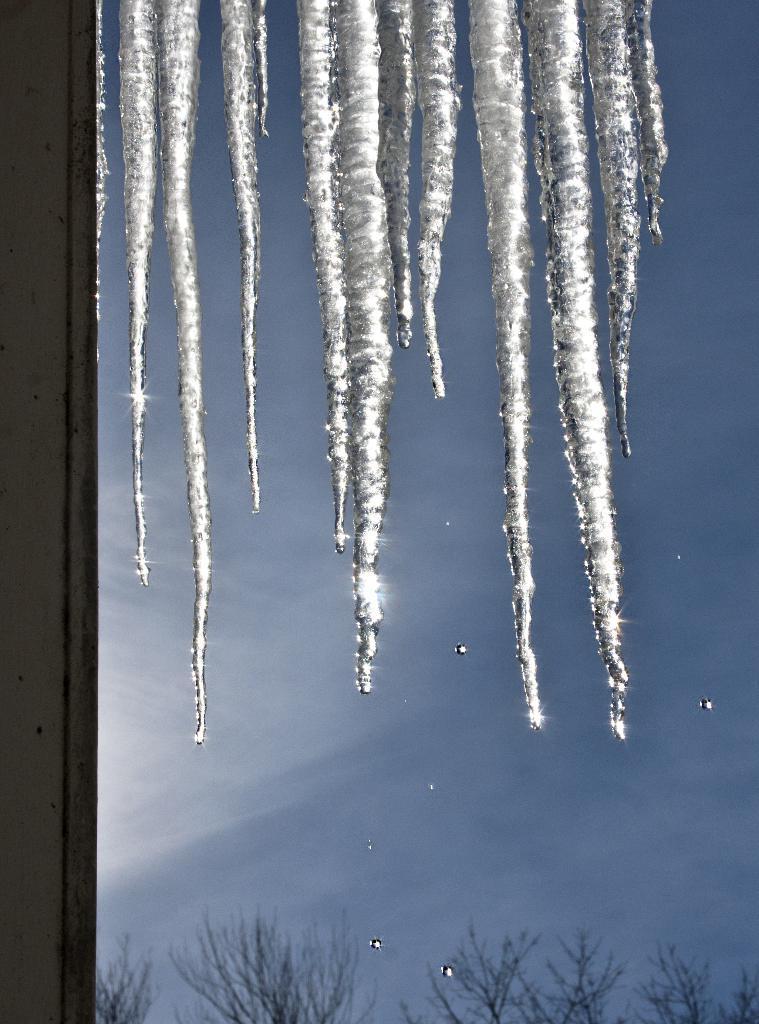Please provide a concise description of this image. In this picture, we can see ice, trees, and the sky, we can see some object on the left side of the picture. 